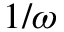Convert formula to latex. <formula><loc_0><loc_0><loc_500><loc_500>1 / \omega</formula> 